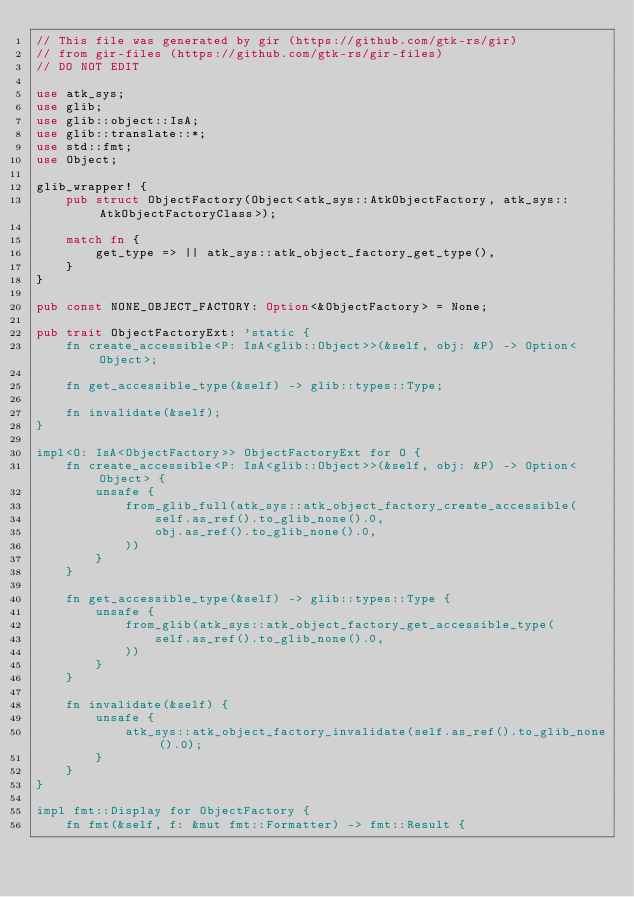Convert code to text. <code><loc_0><loc_0><loc_500><loc_500><_Rust_>// This file was generated by gir (https://github.com/gtk-rs/gir)
// from gir-files (https://github.com/gtk-rs/gir-files)
// DO NOT EDIT

use atk_sys;
use glib;
use glib::object::IsA;
use glib::translate::*;
use std::fmt;
use Object;

glib_wrapper! {
    pub struct ObjectFactory(Object<atk_sys::AtkObjectFactory, atk_sys::AtkObjectFactoryClass>);

    match fn {
        get_type => || atk_sys::atk_object_factory_get_type(),
    }
}

pub const NONE_OBJECT_FACTORY: Option<&ObjectFactory> = None;

pub trait ObjectFactoryExt: 'static {
    fn create_accessible<P: IsA<glib::Object>>(&self, obj: &P) -> Option<Object>;

    fn get_accessible_type(&self) -> glib::types::Type;

    fn invalidate(&self);
}

impl<O: IsA<ObjectFactory>> ObjectFactoryExt for O {
    fn create_accessible<P: IsA<glib::Object>>(&self, obj: &P) -> Option<Object> {
        unsafe {
            from_glib_full(atk_sys::atk_object_factory_create_accessible(
                self.as_ref().to_glib_none().0,
                obj.as_ref().to_glib_none().0,
            ))
        }
    }

    fn get_accessible_type(&self) -> glib::types::Type {
        unsafe {
            from_glib(atk_sys::atk_object_factory_get_accessible_type(
                self.as_ref().to_glib_none().0,
            ))
        }
    }

    fn invalidate(&self) {
        unsafe {
            atk_sys::atk_object_factory_invalidate(self.as_ref().to_glib_none().0);
        }
    }
}

impl fmt::Display for ObjectFactory {
    fn fmt(&self, f: &mut fmt::Formatter) -> fmt::Result {</code> 